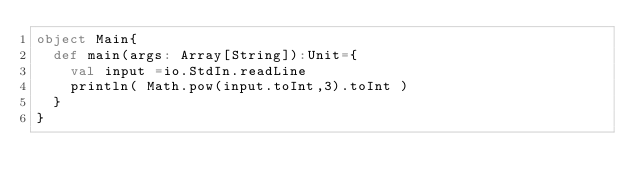Convert code to text. <code><loc_0><loc_0><loc_500><loc_500><_Scala_>object Main{
	def main(args: Array[String]):Unit={
		val input =io.StdIn.readLine
		println( Math.pow(input.toInt,3).toInt )
	}
}</code> 